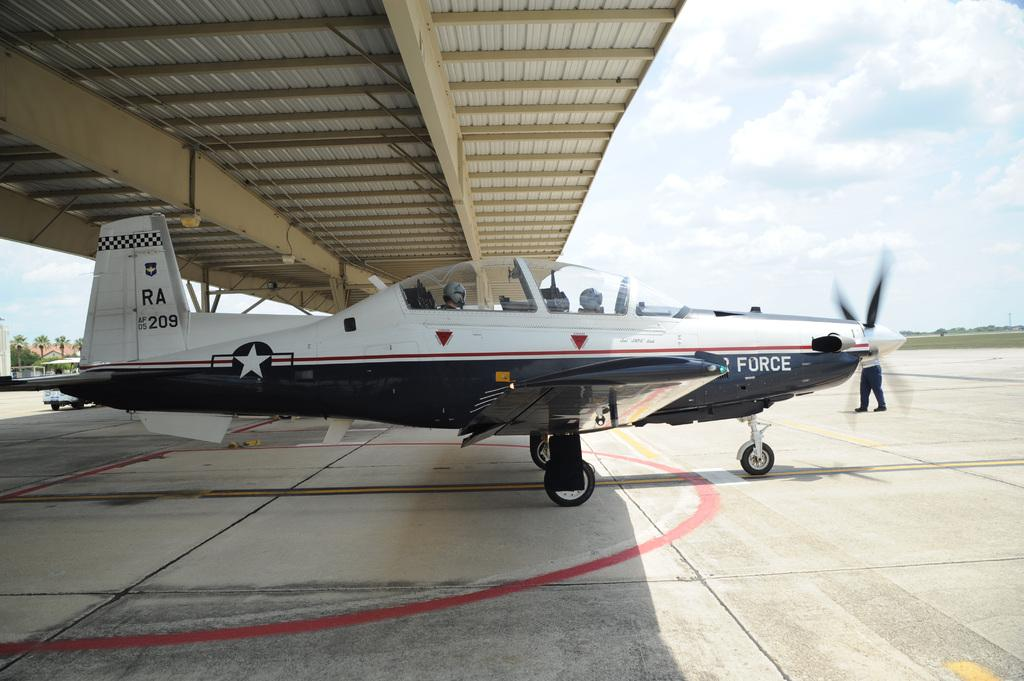<image>
Create a compact narrative representing the image presented. an Air Force propeller plane with RA on the tail 